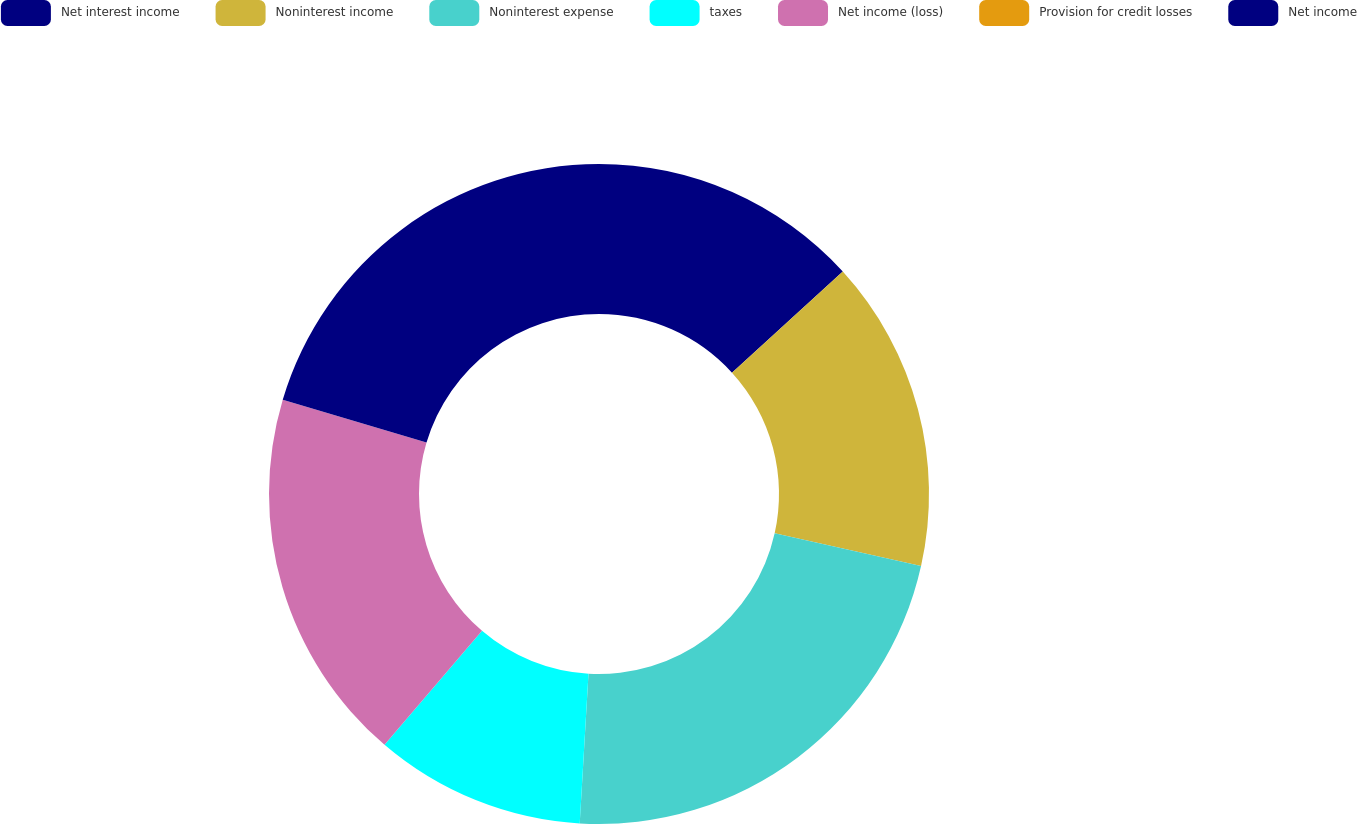<chart> <loc_0><loc_0><loc_500><loc_500><pie_chart><fcel>Net interest income<fcel>Noninterest income<fcel>Noninterest expense<fcel>taxes<fcel>Net income (loss)<fcel>Provision for credit losses<fcel>Net income<nl><fcel>13.23%<fcel>15.27%<fcel>22.43%<fcel>10.33%<fcel>18.35%<fcel>0.0%<fcel>20.39%<nl></chart> 